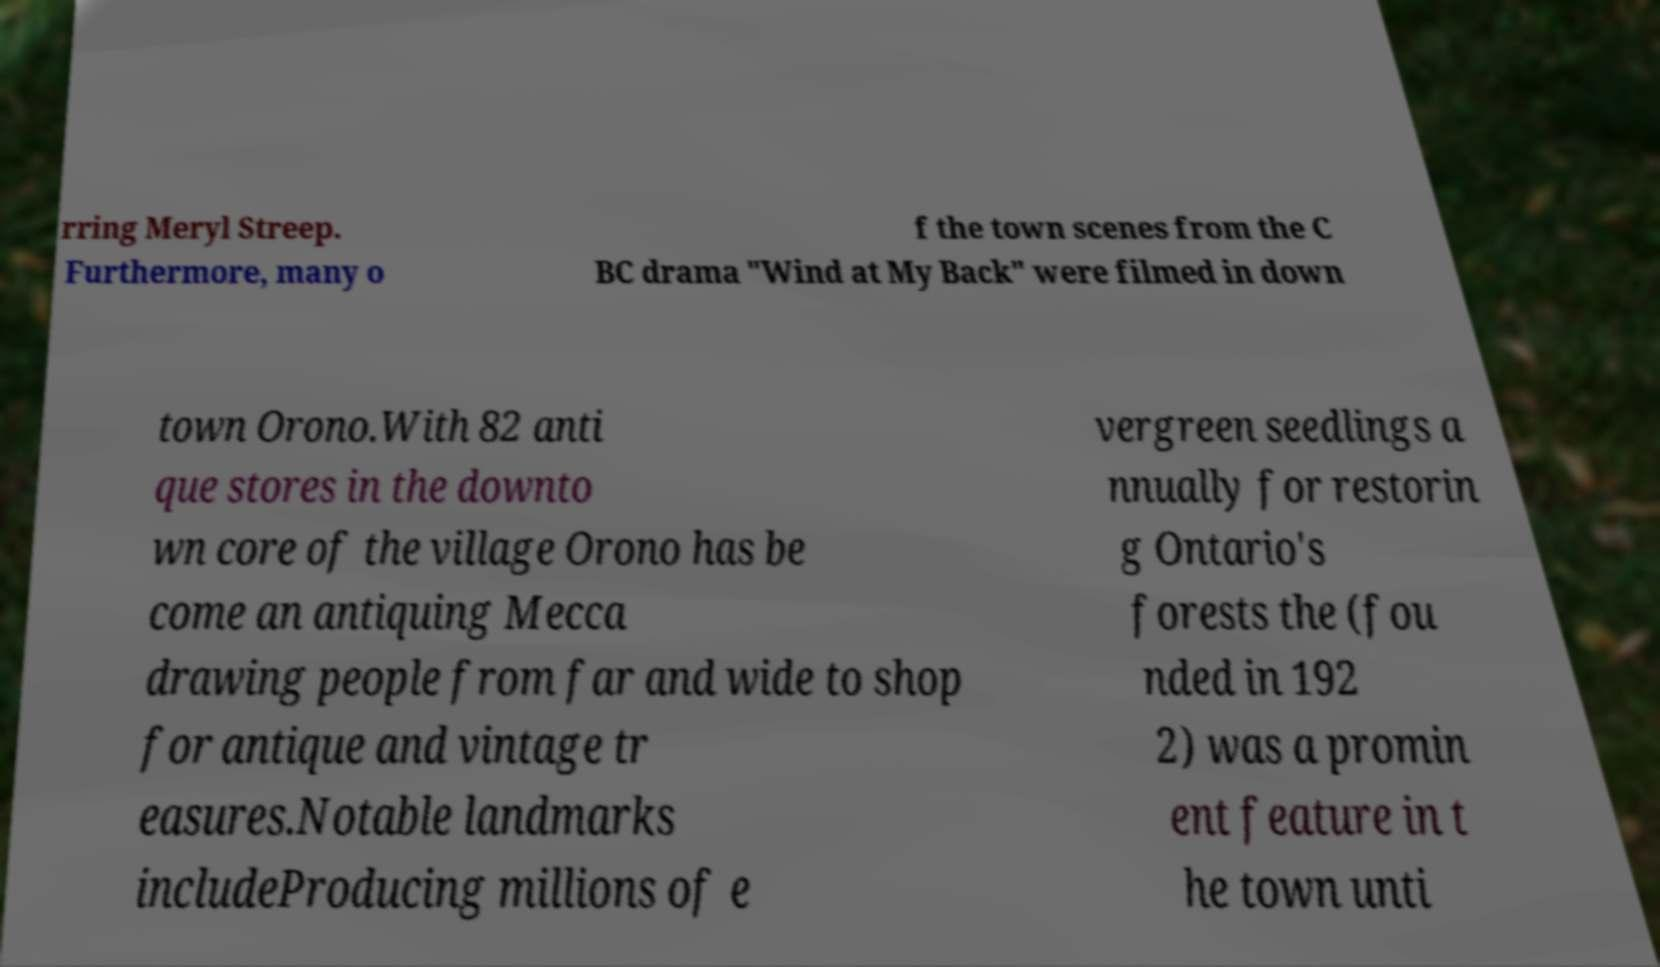Can you accurately transcribe the text from the provided image for me? rring Meryl Streep. Furthermore, many o f the town scenes from the C BC drama "Wind at My Back" were filmed in down town Orono.With 82 anti que stores in the downto wn core of the village Orono has be come an antiquing Mecca drawing people from far and wide to shop for antique and vintage tr easures.Notable landmarks includeProducing millions of e vergreen seedlings a nnually for restorin g Ontario's forests the (fou nded in 192 2) was a promin ent feature in t he town unti 